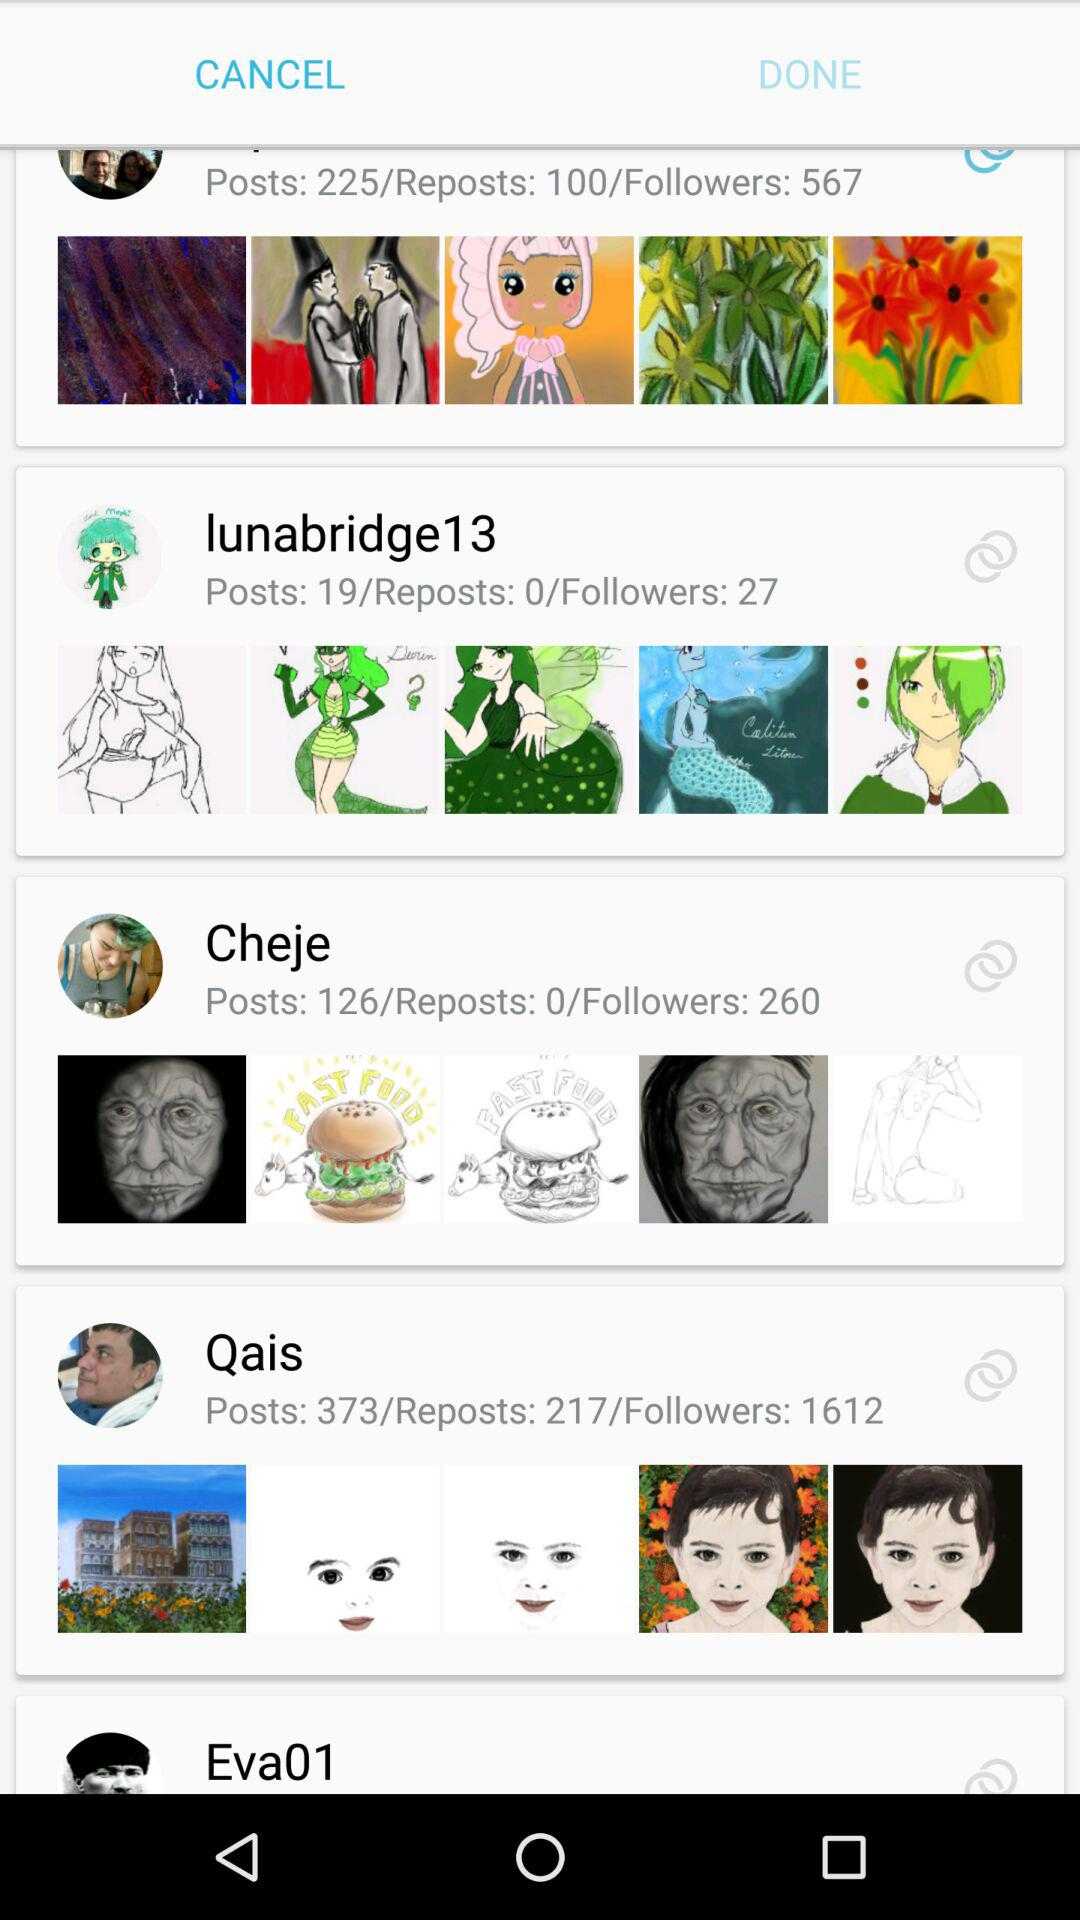How many posts are there on lunabridge13? There are 19 posts. 